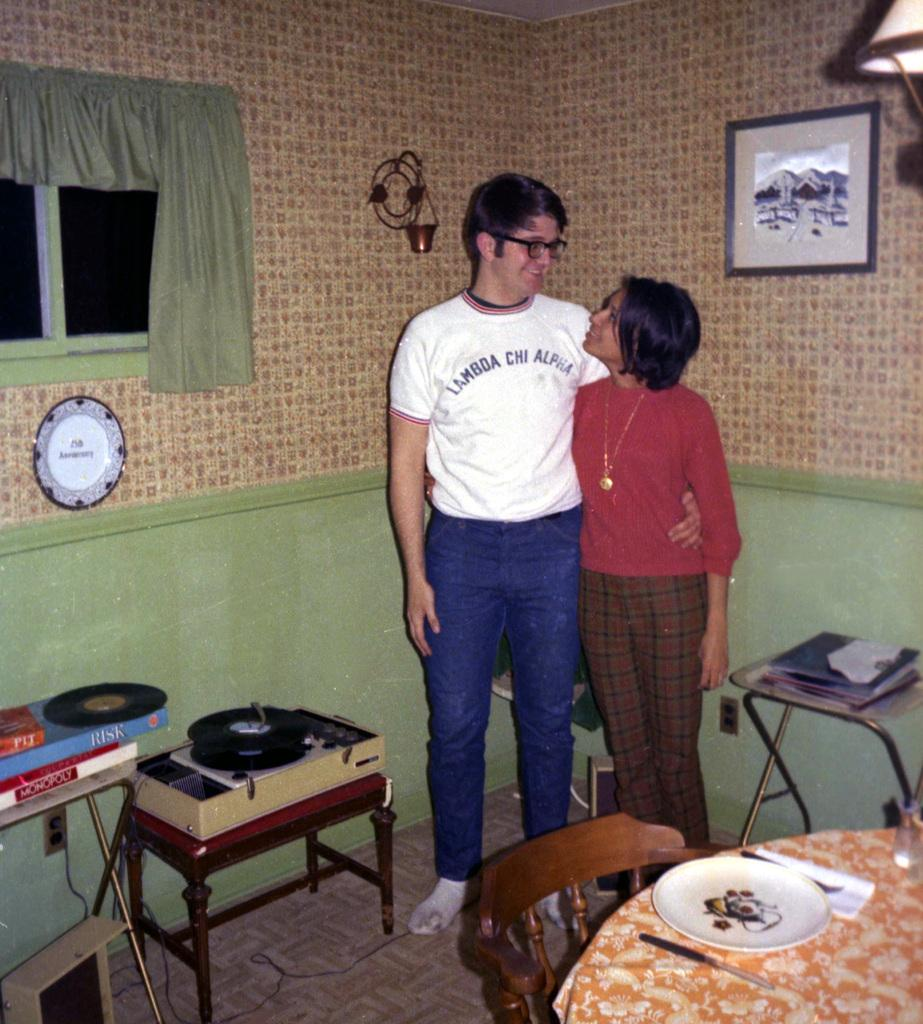<image>
Give a short and clear explanation of the subsequent image. Man wearing a Lamboa Chi Alpha shirt standing next to a woman. 